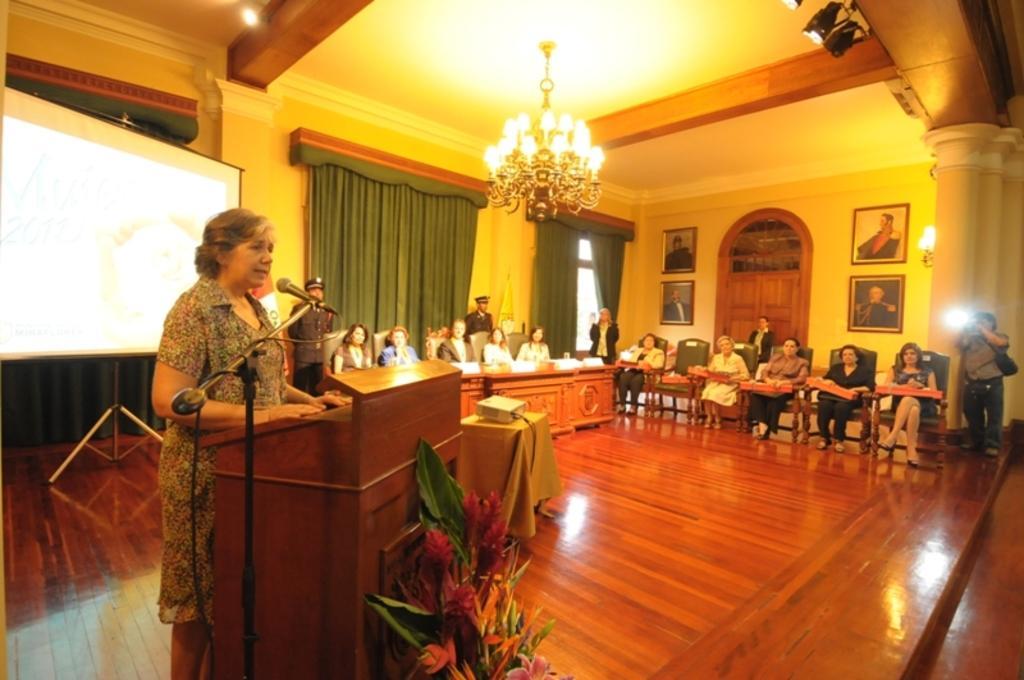Can you describe this image briefly? There are people standing and few people sitting on chairs. We can see microphone with stand, plant, floor, flowers, podium and projector on the table. In the background we can see table with stand, curtains, frames on the wall, light and door. We can see boards and objects on the table. At the top we can see chandelier and lights. 